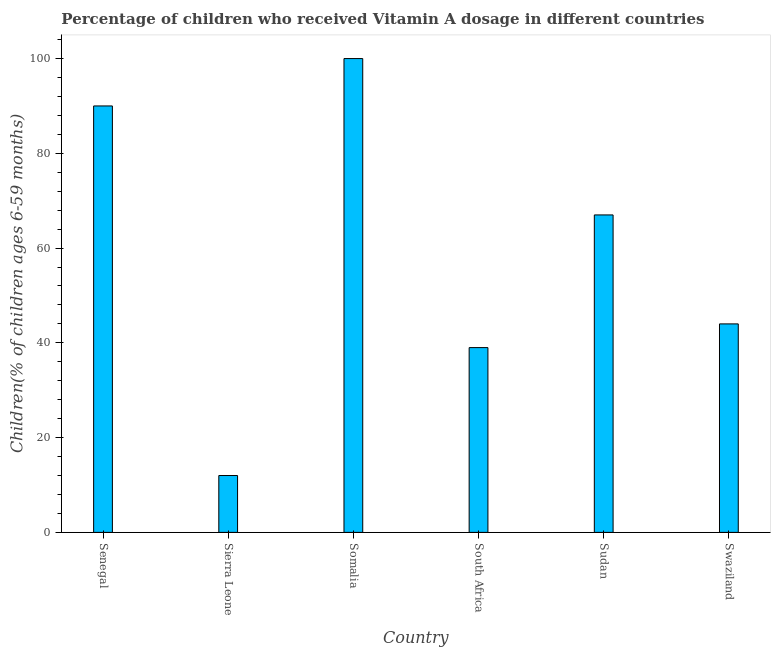Does the graph contain grids?
Provide a succinct answer. No. What is the title of the graph?
Your answer should be compact. Percentage of children who received Vitamin A dosage in different countries. What is the label or title of the X-axis?
Your answer should be very brief. Country. What is the label or title of the Y-axis?
Provide a short and direct response. Children(% of children ages 6-59 months). Across all countries, what is the maximum vitamin a supplementation coverage rate?
Your answer should be compact. 100. Across all countries, what is the minimum vitamin a supplementation coverage rate?
Your answer should be very brief. 12. In which country was the vitamin a supplementation coverage rate maximum?
Provide a succinct answer. Somalia. In which country was the vitamin a supplementation coverage rate minimum?
Ensure brevity in your answer.  Sierra Leone. What is the sum of the vitamin a supplementation coverage rate?
Give a very brief answer. 352. What is the difference between the vitamin a supplementation coverage rate in Sierra Leone and Swaziland?
Offer a very short reply. -32. What is the average vitamin a supplementation coverage rate per country?
Your answer should be very brief. 58.67. What is the median vitamin a supplementation coverage rate?
Give a very brief answer. 55.5. What is the ratio of the vitamin a supplementation coverage rate in Sudan to that in Swaziland?
Make the answer very short. 1.52. Is the vitamin a supplementation coverage rate in Senegal less than that in Sierra Leone?
Ensure brevity in your answer.  No. What is the difference between the highest and the second highest vitamin a supplementation coverage rate?
Your response must be concise. 10. How many bars are there?
Keep it short and to the point. 6. How many countries are there in the graph?
Offer a terse response. 6. What is the difference between two consecutive major ticks on the Y-axis?
Provide a short and direct response. 20. Are the values on the major ticks of Y-axis written in scientific E-notation?
Ensure brevity in your answer.  No. What is the Children(% of children ages 6-59 months) of Senegal?
Provide a succinct answer. 90. What is the Children(% of children ages 6-59 months) in Sierra Leone?
Provide a succinct answer. 12. What is the Children(% of children ages 6-59 months) of Somalia?
Your answer should be compact. 100. What is the Children(% of children ages 6-59 months) in South Africa?
Offer a very short reply. 39. What is the difference between the Children(% of children ages 6-59 months) in Senegal and Sierra Leone?
Offer a terse response. 78. What is the difference between the Children(% of children ages 6-59 months) in Senegal and Swaziland?
Make the answer very short. 46. What is the difference between the Children(% of children ages 6-59 months) in Sierra Leone and Somalia?
Offer a very short reply. -88. What is the difference between the Children(% of children ages 6-59 months) in Sierra Leone and Sudan?
Your response must be concise. -55. What is the difference between the Children(% of children ages 6-59 months) in Sierra Leone and Swaziland?
Make the answer very short. -32. What is the difference between the Children(% of children ages 6-59 months) in Somalia and South Africa?
Your response must be concise. 61. What is the difference between the Children(% of children ages 6-59 months) in Somalia and Sudan?
Ensure brevity in your answer.  33. What is the difference between the Children(% of children ages 6-59 months) in South Africa and Sudan?
Make the answer very short. -28. What is the difference between the Children(% of children ages 6-59 months) in South Africa and Swaziland?
Keep it short and to the point. -5. What is the difference between the Children(% of children ages 6-59 months) in Sudan and Swaziland?
Ensure brevity in your answer.  23. What is the ratio of the Children(% of children ages 6-59 months) in Senegal to that in Somalia?
Offer a terse response. 0.9. What is the ratio of the Children(% of children ages 6-59 months) in Senegal to that in South Africa?
Your answer should be very brief. 2.31. What is the ratio of the Children(% of children ages 6-59 months) in Senegal to that in Sudan?
Offer a very short reply. 1.34. What is the ratio of the Children(% of children ages 6-59 months) in Senegal to that in Swaziland?
Make the answer very short. 2.04. What is the ratio of the Children(% of children ages 6-59 months) in Sierra Leone to that in Somalia?
Give a very brief answer. 0.12. What is the ratio of the Children(% of children ages 6-59 months) in Sierra Leone to that in South Africa?
Give a very brief answer. 0.31. What is the ratio of the Children(% of children ages 6-59 months) in Sierra Leone to that in Sudan?
Your answer should be compact. 0.18. What is the ratio of the Children(% of children ages 6-59 months) in Sierra Leone to that in Swaziland?
Give a very brief answer. 0.27. What is the ratio of the Children(% of children ages 6-59 months) in Somalia to that in South Africa?
Keep it short and to the point. 2.56. What is the ratio of the Children(% of children ages 6-59 months) in Somalia to that in Sudan?
Provide a succinct answer. 1.49. What is the ratio of the Children(% of children ages 6-59 months) in Somalia to that in Swaziland?
Your answer should be very brief. 2.27. What is the ratio of the Children(% of children ages 6-59 months) in South Africa to that in Sudan?
Your answer should be very brief. 0.58. What is the ratio of the Children(% of children ages 6-59 months) in South Africa to that in Swaziland?
Provide a succinct answer. 0.89. What is the ratio of the Children(% of children ages 6-59 months) in Sudan to that in Swaziland?
Ensure brevity in your answer.  1.52. 